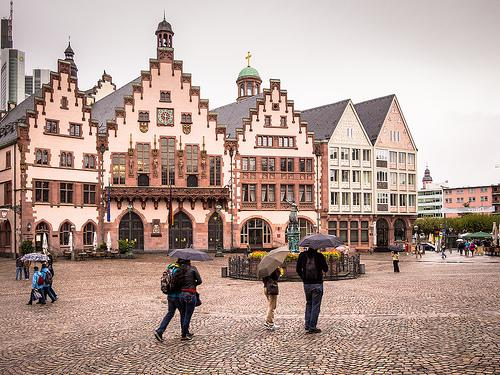Question: what are the people holding?
Choices:
A. Signs.
B. Hamburgers.
C. Sodas.
D. Umbrellas.
Answer with the letter. Answer: D Question: how many legs do the people have?
Choices:
A. Three.
B. One.
C. None.
D. Two.
Answer with the letter. Answer: D Question: how many statues are in the fountain?
Choices:
A. One.
B. Two.
C. Three.
D. Six.
Answer with the letter. Answer: A 